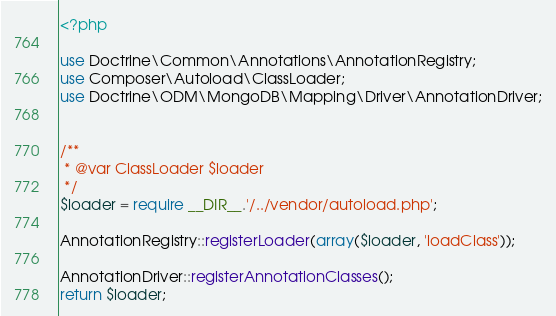<code> <loc_0><loc_0><loc_500><loc_500><_PHP_><?php

use Doctrine\Common\Annotations\AnnotationRegistry;
use Composer\Autoload\ClassLoader;
use Doctrine\ODM\MongoDB\Mapping\Driver\AnnotationDriver;


/**
 * @var ClassLoader $loader
 */
$loader = require __DIR__.'/../vendor/autoload.php';

AnnotationRegistry::registerLoader(array($loader, 'loadClass'));

AnnotationDriver::registerAnnotationClasses();
return $loader;
</code> 